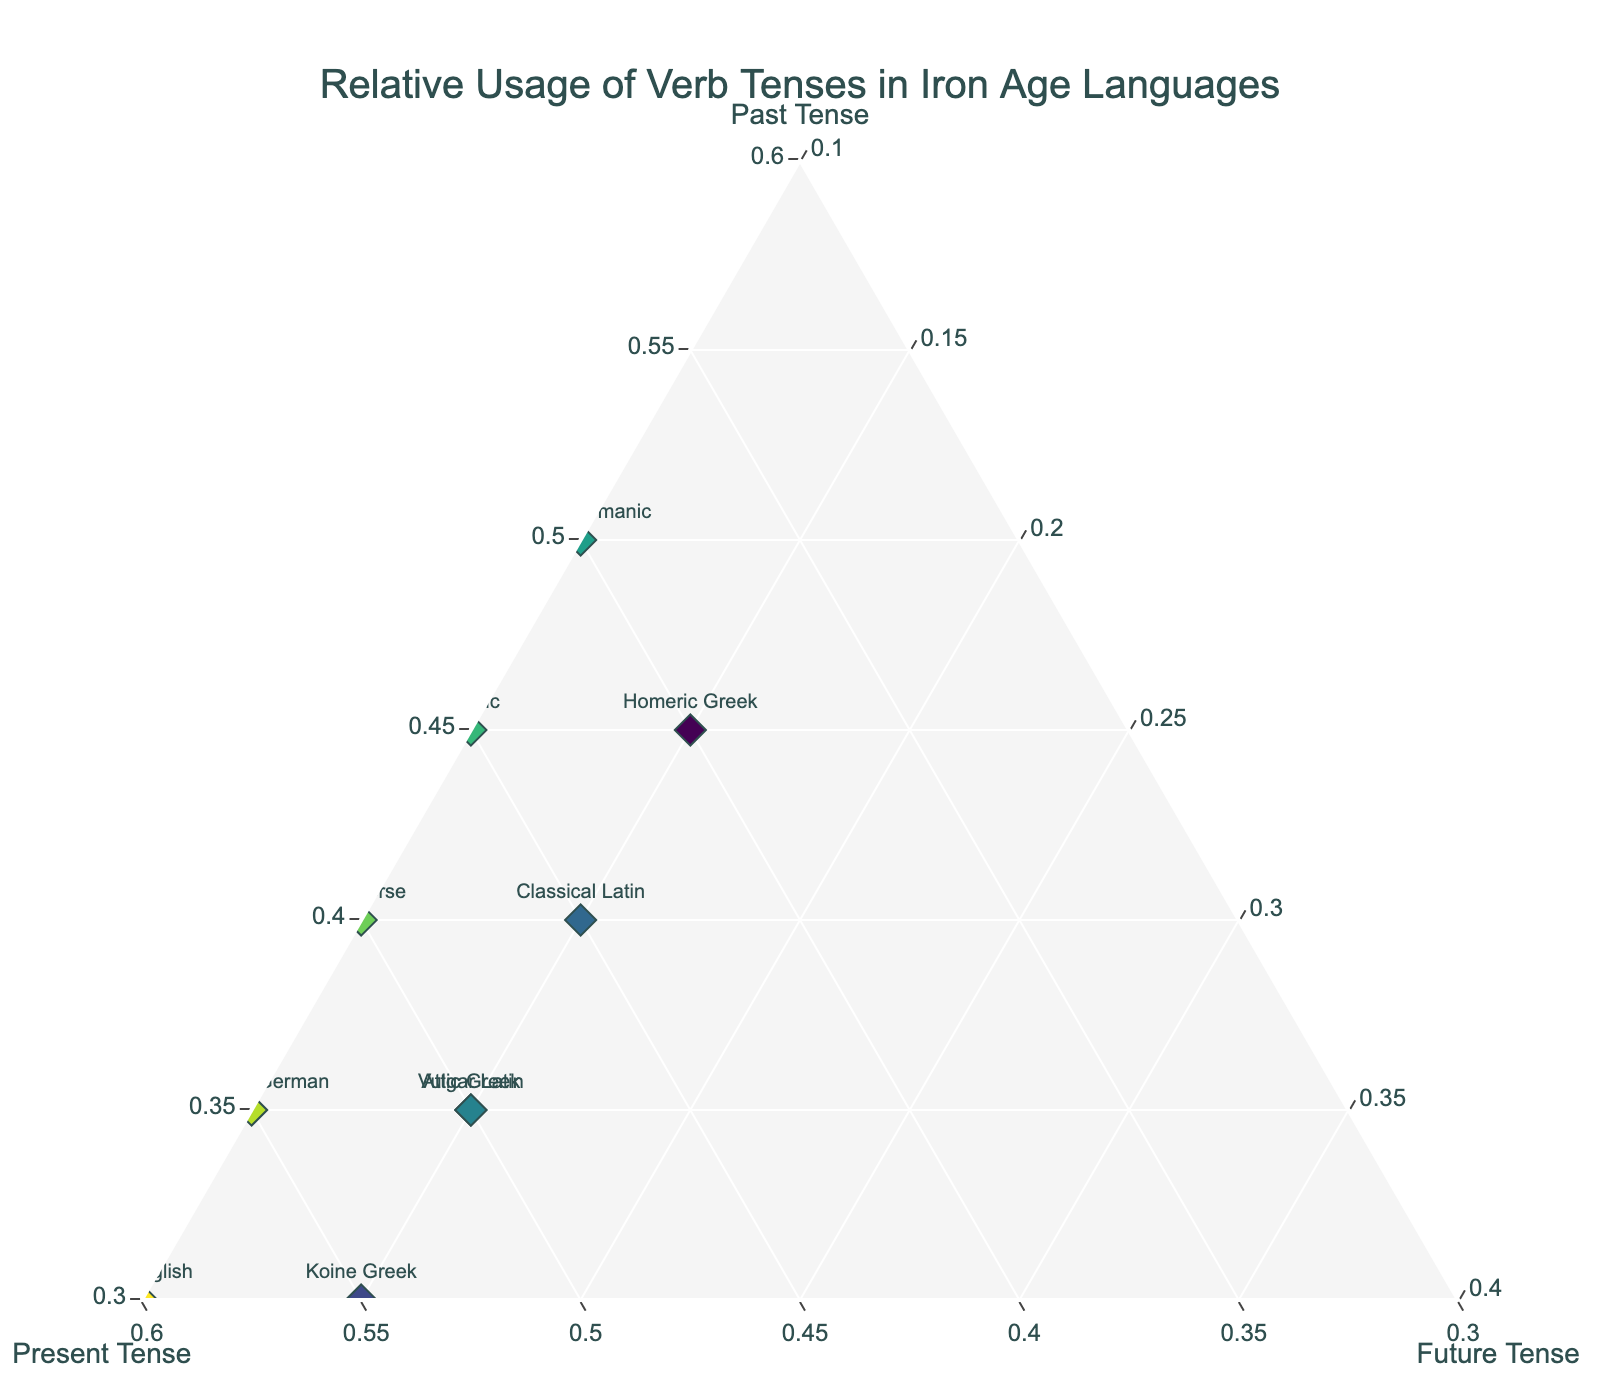Which language has the highest relative use of the present tense? Look for the data point furthest along the Present Tense axis.
Answer: Old English Which languages have an identical distribution of future tense usage? Find languages that share the same value along the Future Tense axis.
Answer: Homeric Greek, Attic Greek, Koine Greek, Classical Latin, Vulgar Latin What is the sum of the relative present tense usage for Koine Greek and Old High German? Find the relative present tense values for Koine Greek and Old High German and add them together (55% + 55%).
Answer: 110% Which language has the lowest relative usage of the future tense? Check which data point is located the furthest away from the Future Tense axis.
Answer: Proto-Germanic How does the relative present tense usage of Homeric Greek compare to Proto-Germanic? Check the values for the present tense usage of both languages: Homeric Greek has 40% and Proto-Germanic has 40%.
Answer: Equal Which language group has the highest relative usage of past tense? Look for the data point furthest along the Past Tense axis.
Answer: Proto-Germanic Is there a trend in the usage of the present tense between Proto-Germanic to Old English? Calculate if present tense usage increases or decreases from Proto-Germanic through Gothic, Old Norse, and Old High German to Old English: 40% (Proto-Germanic), 45% (Gothic), 50% (Old Norse), 55% (Old High German), 60% (Old English).
Answer: Increasing How many languages use the future tense at exactly 15%? Count the number of data points with a future tense usage of 15%.
Answer: 5 Which languages have identical past tense usage? Identify languages that have the same relative amount of past tense usage: 45% (Homeric Greek, Gothic), 35% (Attic Greek, Vulgar Latin, Old High German), 40% (Classical Latin, Old Norse), 30% (Koine Greek, Old English).
Answer: Homeric Greek and Gothic, Attic Greek, Vulgar Latin, and Old High German, Classical Latin and Old Norse, Koine Greek and Old English What is the difference in relative present tense usage between Classical Latin and Attic Greek? Subtract the present tense usage of Classical Latin (45%) from Attic Greek (50%).
Answer: 5% 